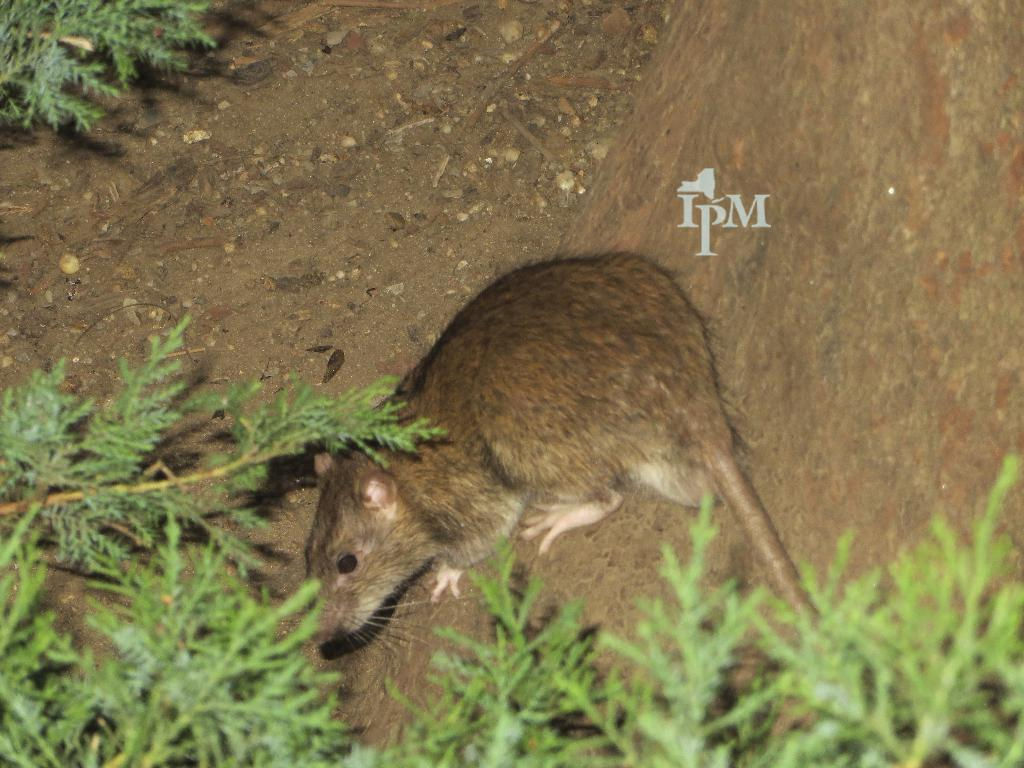What type of living organisms can be seen in the image? Plants are visible in the image. What animal is present on a rock in the image? There is a rat on a rock in the image. Is there any text visible in the image? Yes, there is some text visible in the image. What is the rat doing that causes everyone to laugh in the image? There is no indication in the image that the rat is doing anything to cause laughter, as it is simply sitting on a rock. 